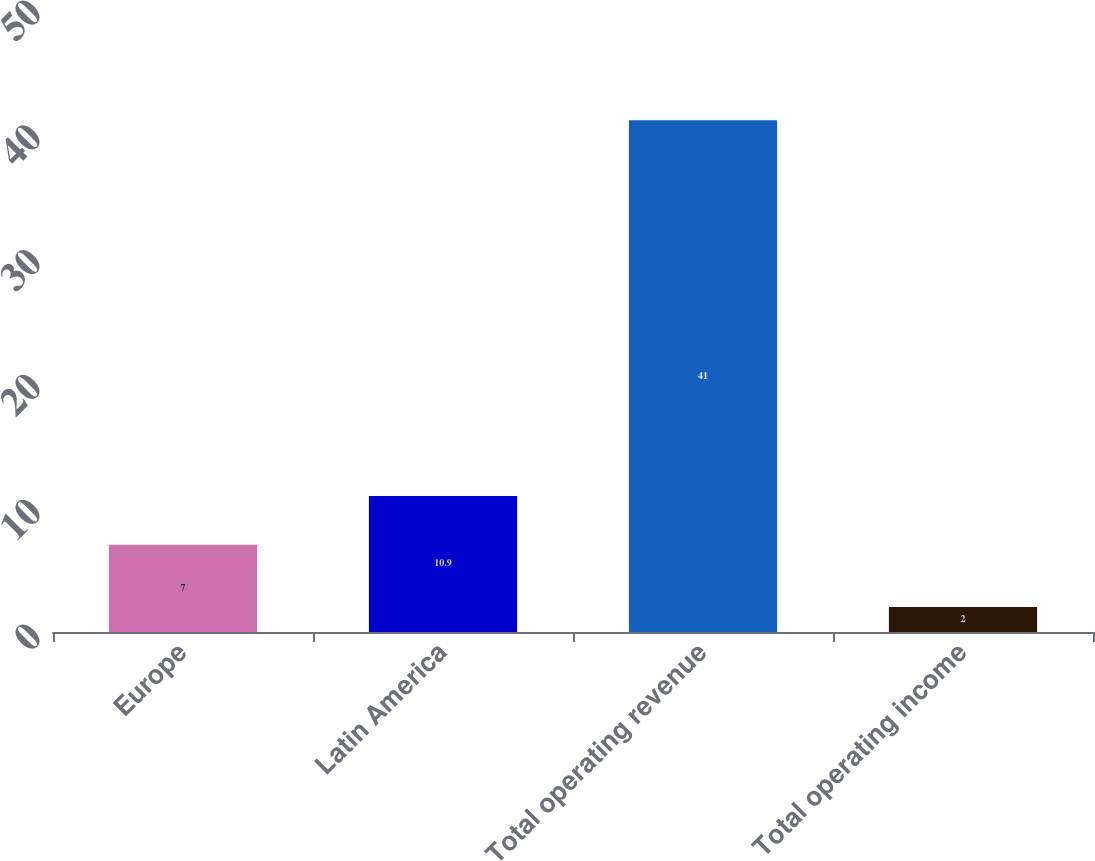<chart> <loc_0><loc_0><loc_500><loc_500><bar_chart><fcel>Europe<fcel>Latin America<fcel>Total operating revenue<fcel>Total operating income<nl><fcel>7<fcel>10.9<fcel>41<fcel>2<nl></chart> 